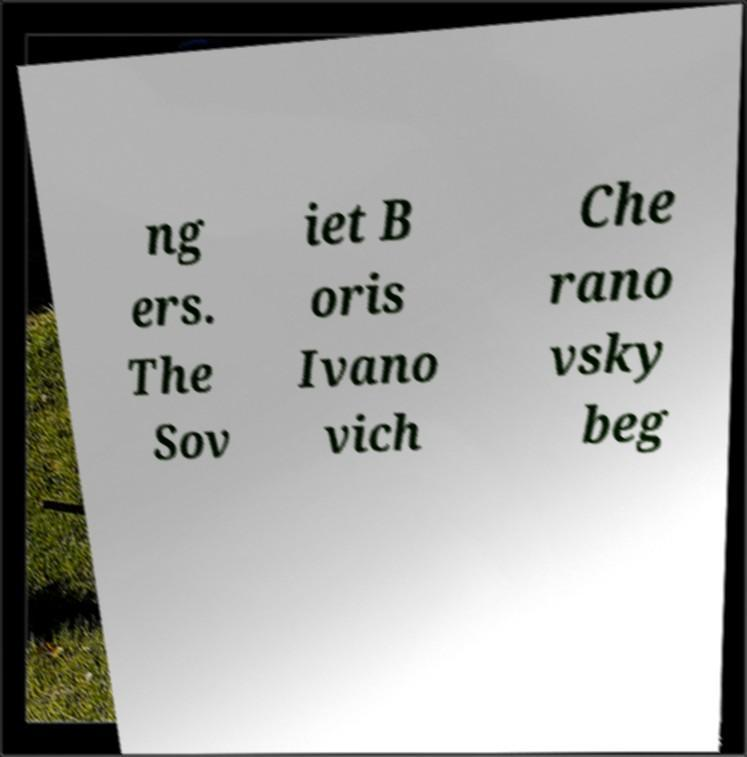Could you extract and type out the text from this image? ng ers. The Sov iet B oris Ivano vich Che rano vsky beg 